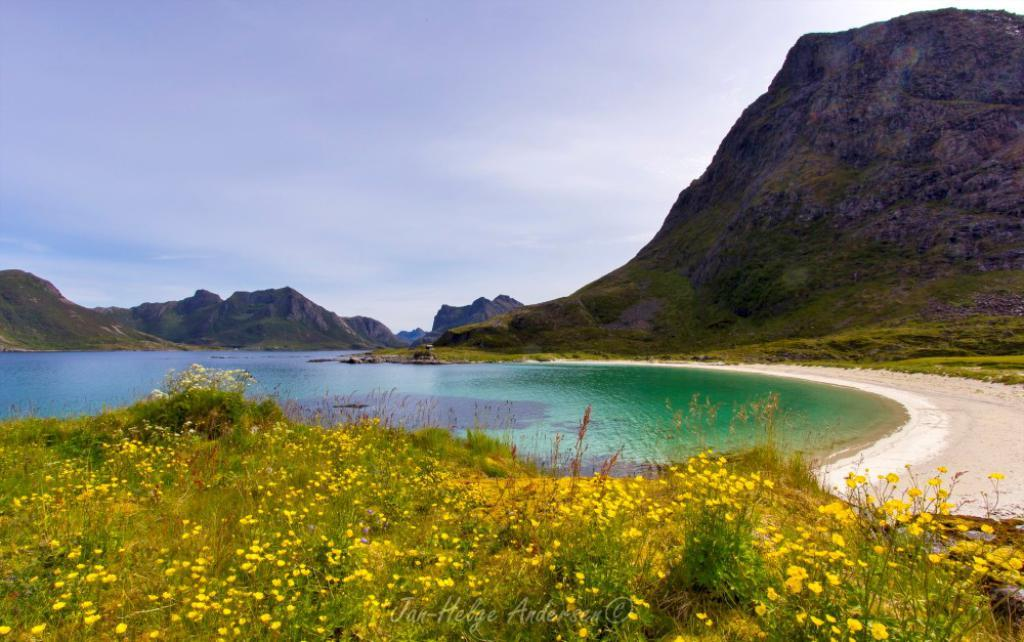What can be seen in the foreground of the picture? There are plants and flowers in the foreground of the picture. What is located in the center of the picture? There is a water body in the center of the picture. What can be seen in the background of the picture? There are mountains in the background of the picture. How would you describe the sky in the picture? The sky is cloudy. How many goldfish can be seen swimming in the water body in the picture? There are no goldfish visible in the water body in the picture. What type of fan is present near the plants and flowers in the foreground? There is no fan present near the plants and flowers in the foreground. 